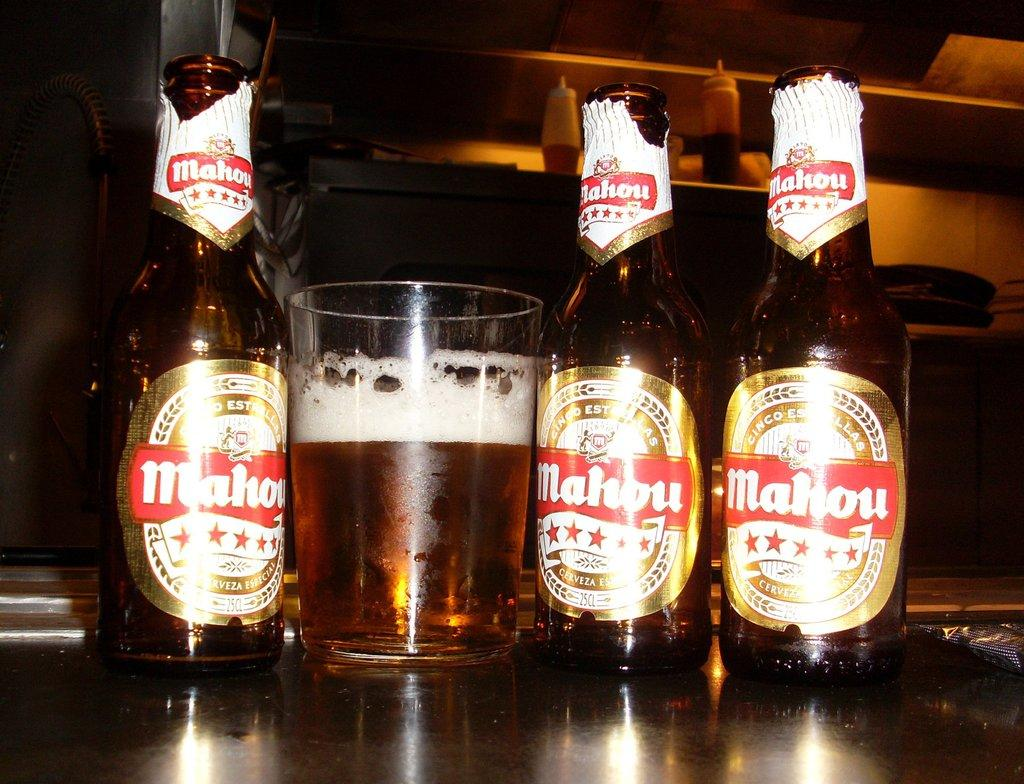How many bottles are on the table in the image? There are three bottles on the table in the image. What else is on the table besides the bottles? There is a glass on the table. What can be seen in the background of the image? There is a shelf in the background. What type of bottles are on the shelf? The shelf contains plastic bottles. Is there a person using a whip to move the bottles on the table in the image? No, there is no person or whip present in the image. 